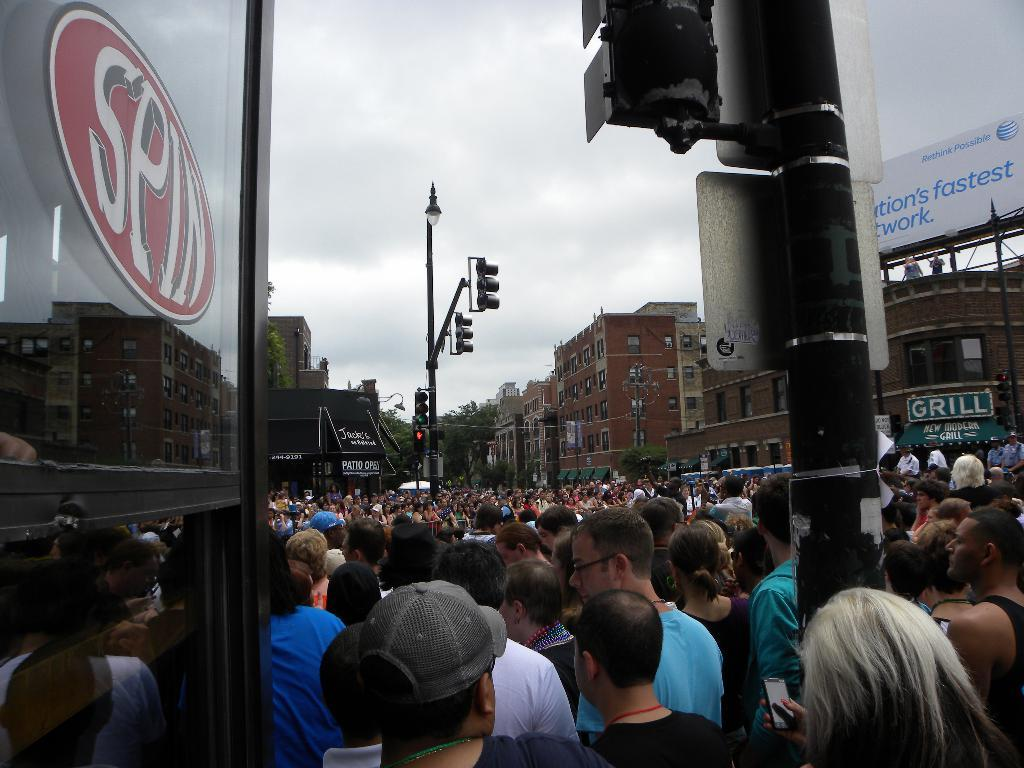What is happening on the road in the image? There are many people standing on the road in the image. What can be seen in the front of the image? There is a glass door and a street pole in the front of the image. What is the color of the buildings in the background of the image? The buildings in the background of the image are brown in color. Are there any other street poles visible in the image? Yes, there is another street pole in the background of the image. What type of hair can be seen on the people in the image? There is no specific hair type mentioned or visible in the image; it only shows people standing on the road. What kind of feast is being prepared in the image? There is no mention or indication of a feast being prepared in the image. 